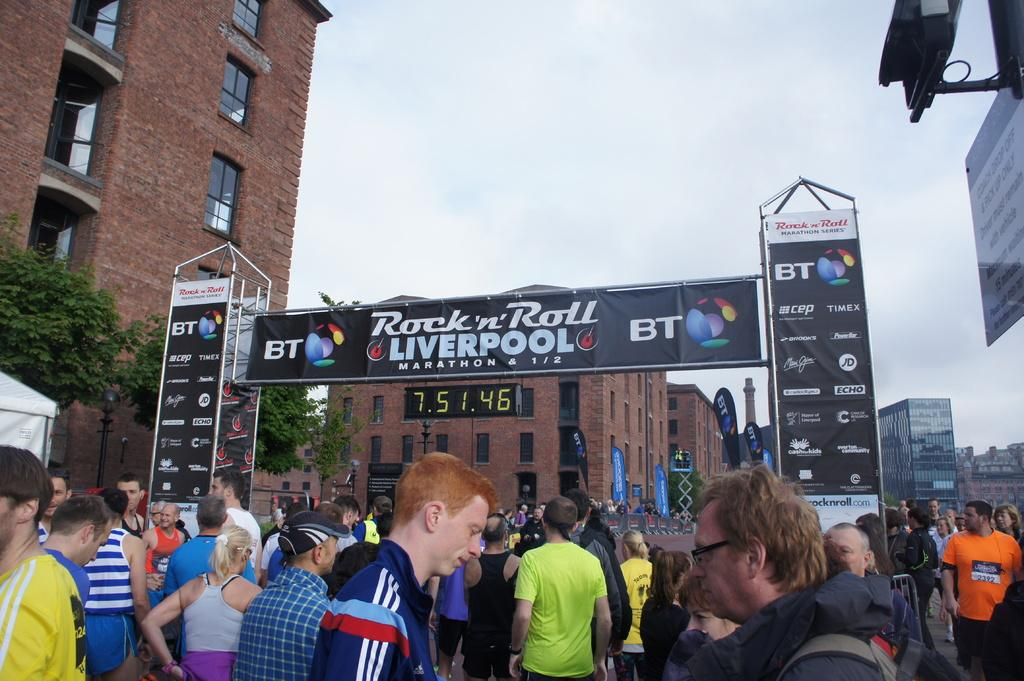Provide a one-sentence caption for the provided image. people waiting at rock n roll liverpool marathon starting gate. 